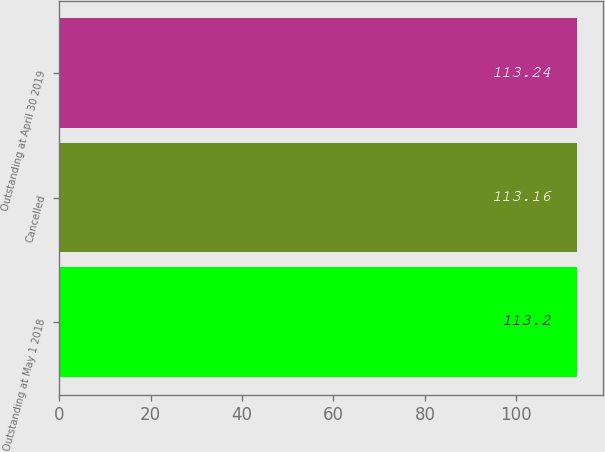<chart> <loc_0><loc_0><loc_500><loc_500><bar_chart><fcel>Outstanding at May 1 2018<fcel>Cancelled<fcel>Outstanding at April 30 2019<nl><fcel>113.2<fcel>113.16<fcel>113.24<nl></chart> 